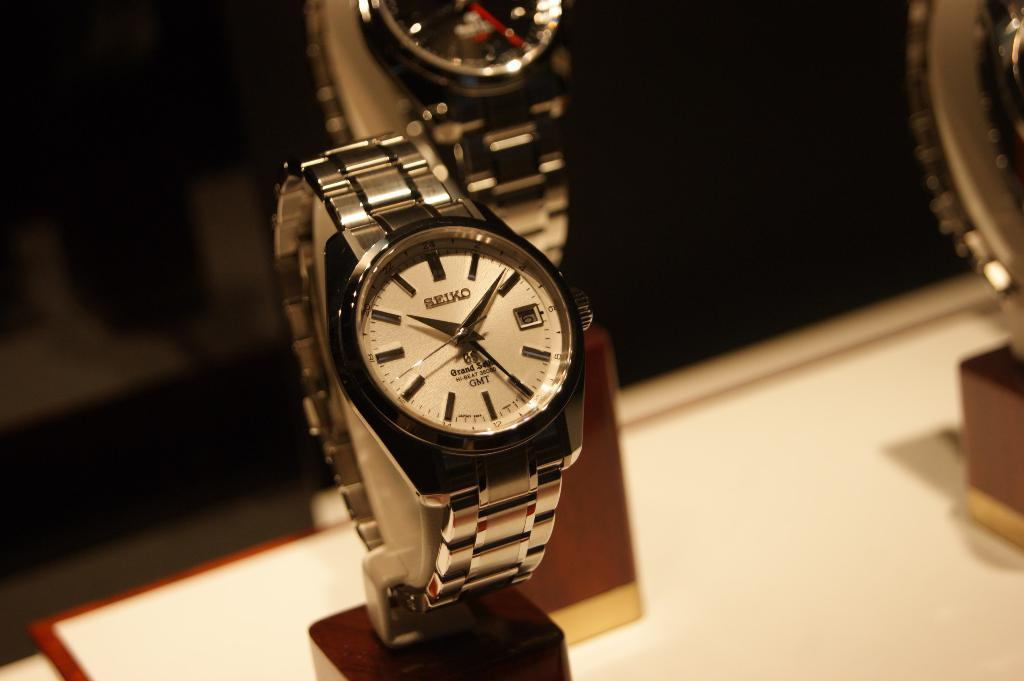Provide a one-sentence caption for the provided image. Wristwatch on display with the word SEIKO on the face. 